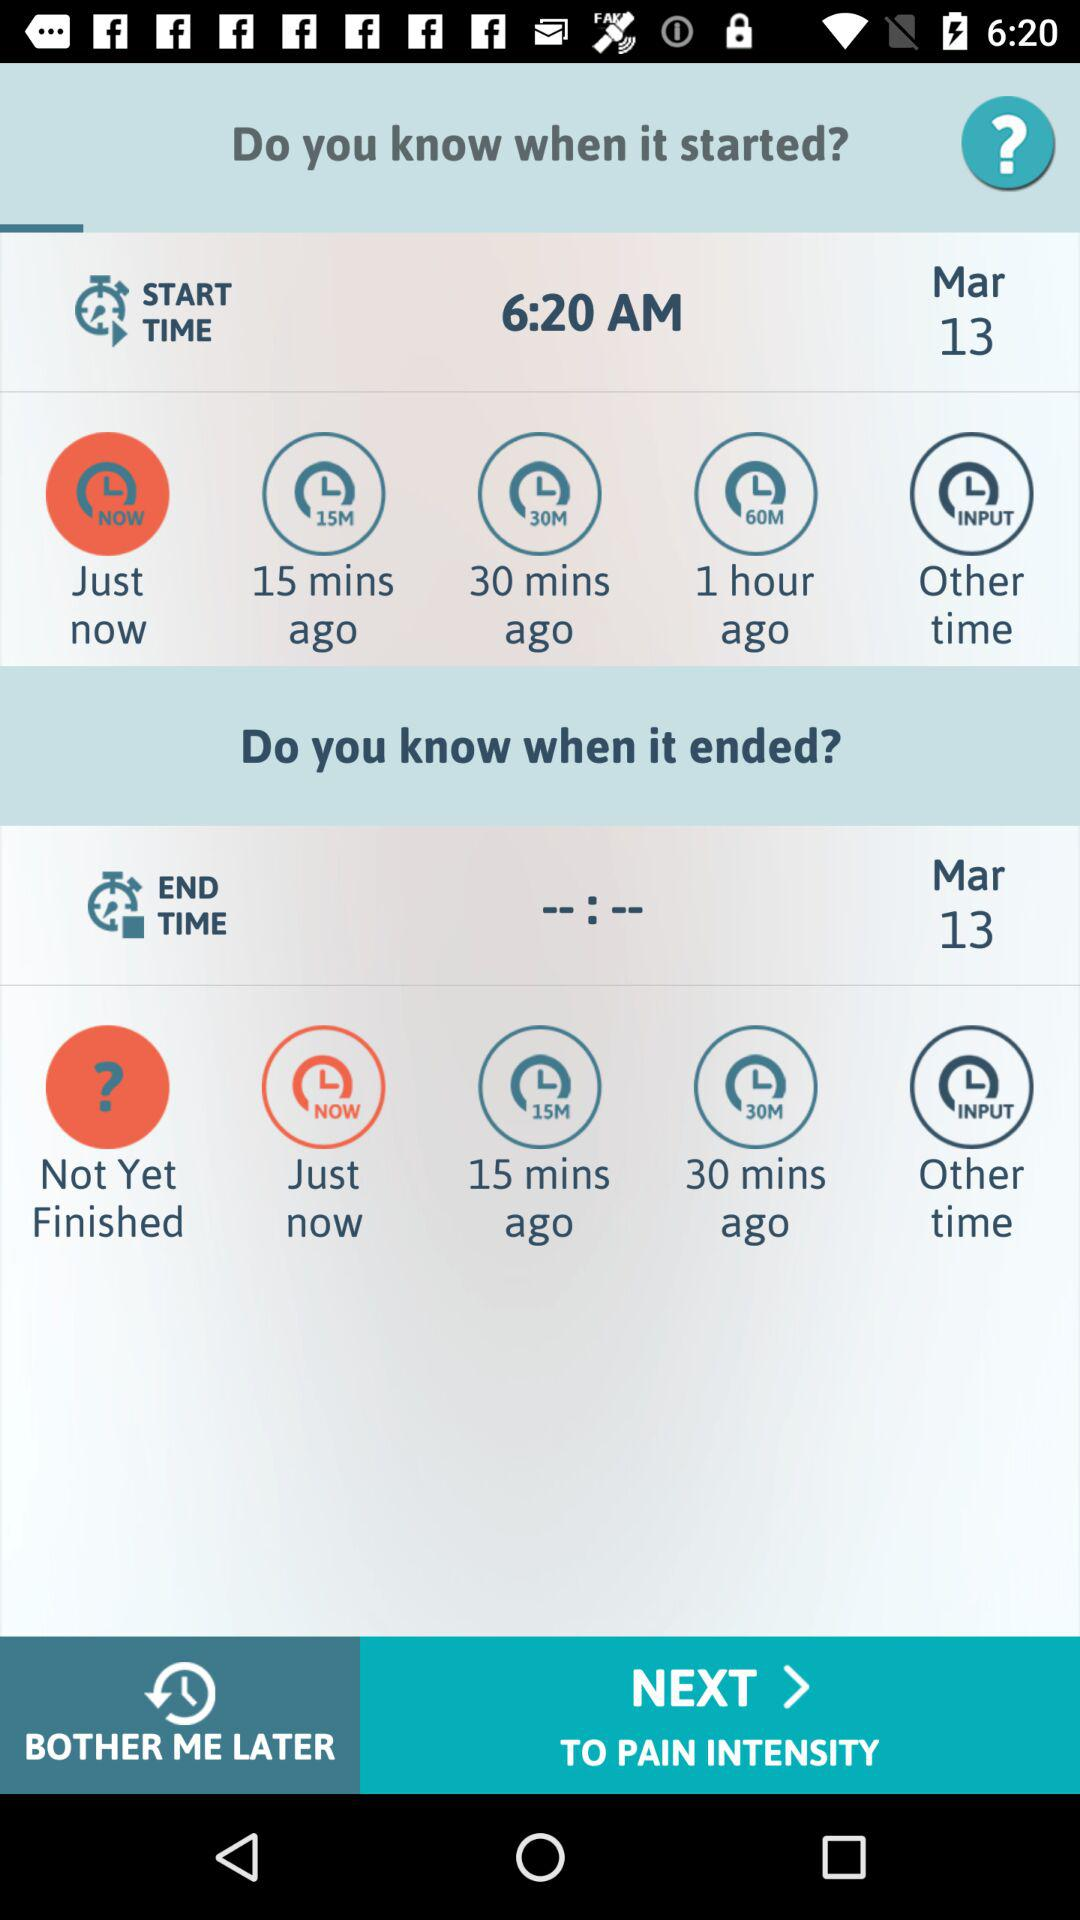What is the start time? The start time is 6:20 AM. 